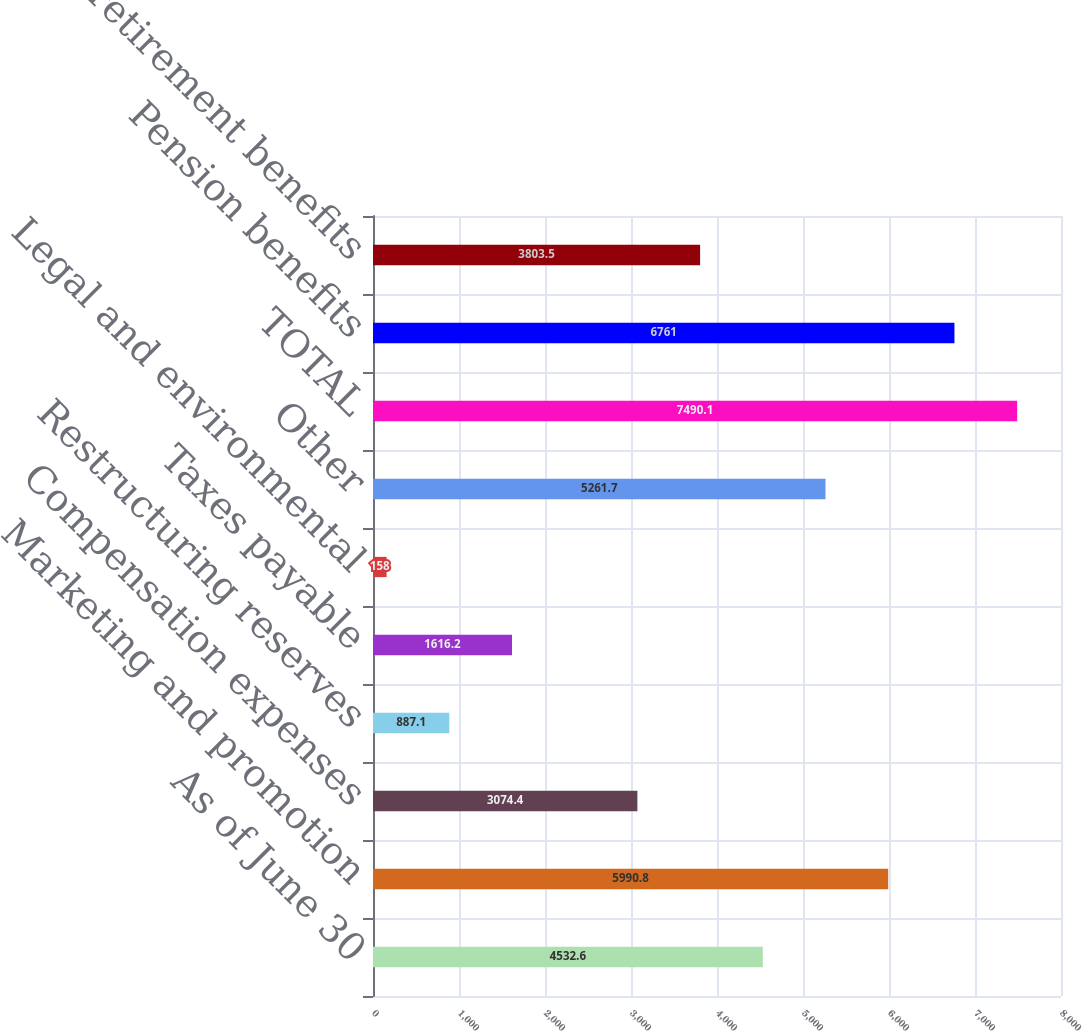Convert chart to OTSL. <chart><loc_0><loc_0><loc_500><loc_500><bar_chart><fcel>As of June 30<fcel>Marketing and promotion<fcel>Compensation expenses<fcel>Restructuring reserves<fcel>Taxes payable<fcel>Legal and environmental<fcel>Other<fcel>TOTAL<fcel>Pension benefits<fcel>Other postretirement benefits<nl><fcel>4532.6<fcel>5990.8<fcel>3074.4<fcel>887.1<fcel>1616.2<fcel>158<fcel>5261.7<fcel>7490.1<fcel>6761<fcel>3803.5<nl></chart> 